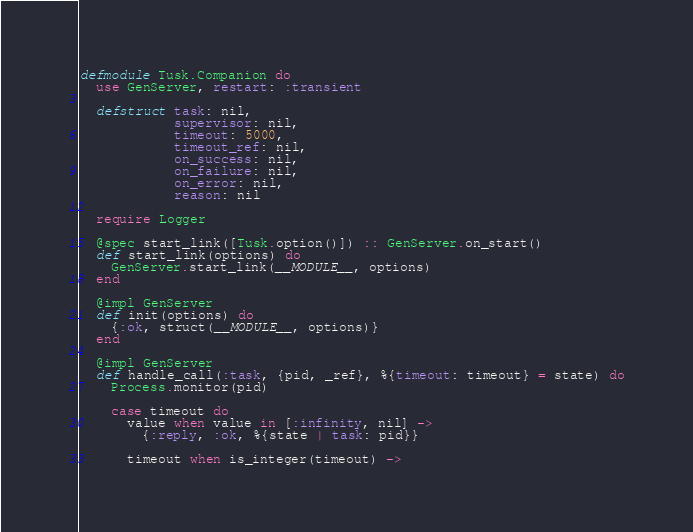Convert code to text. <code><loc_0><loc_0><loc_500><loc_500><_Elixir_>defmodule Tusk.Companion do
  use GenServer, restart: :transient

  defstruct task: nil,
            supervisor: nil,
            timeout: 5000,
            timeout_ref: nil,
            on_success: nil,
            on_failure: nil,
            on_error: nil,
            reason: nil

  require Logger

  @spec start_link([Tusk.option()]) :: GenServer.on_start()
  def start_link(options) do
    GenServer.start_link(__MODULE__, options)
  end

  @impl GenServer
  def init(options) do
    {:ok, struct(__MODULE__, options)}
  end

  @impl GenServer
  def handle_call(:task, {pid, _ref}, %{timeout: timeout} = state) do
    Process.monitor(pid)

    case timeout do
      value when value in [:infinity, nil] ->
        {:reply, :ok, %{state | task: pid}}

      timeout when is_integer(timeout) -></code> 